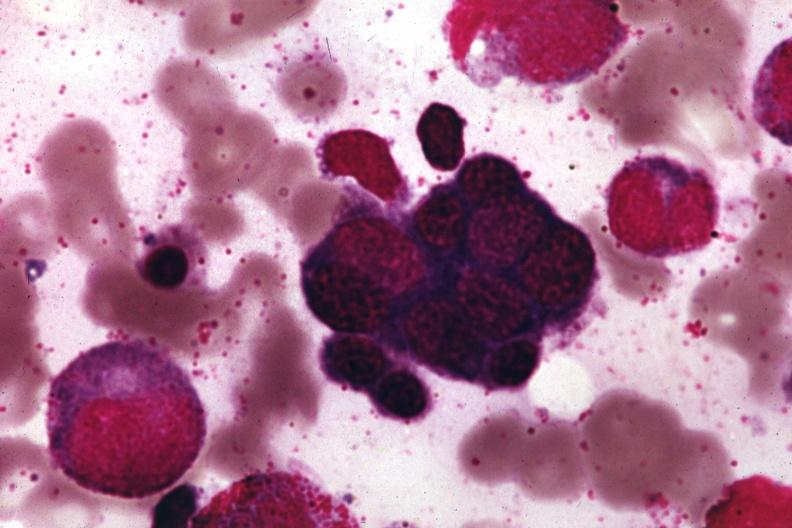s hematologic present?
Answer the question using a single word or phrase. Yes 